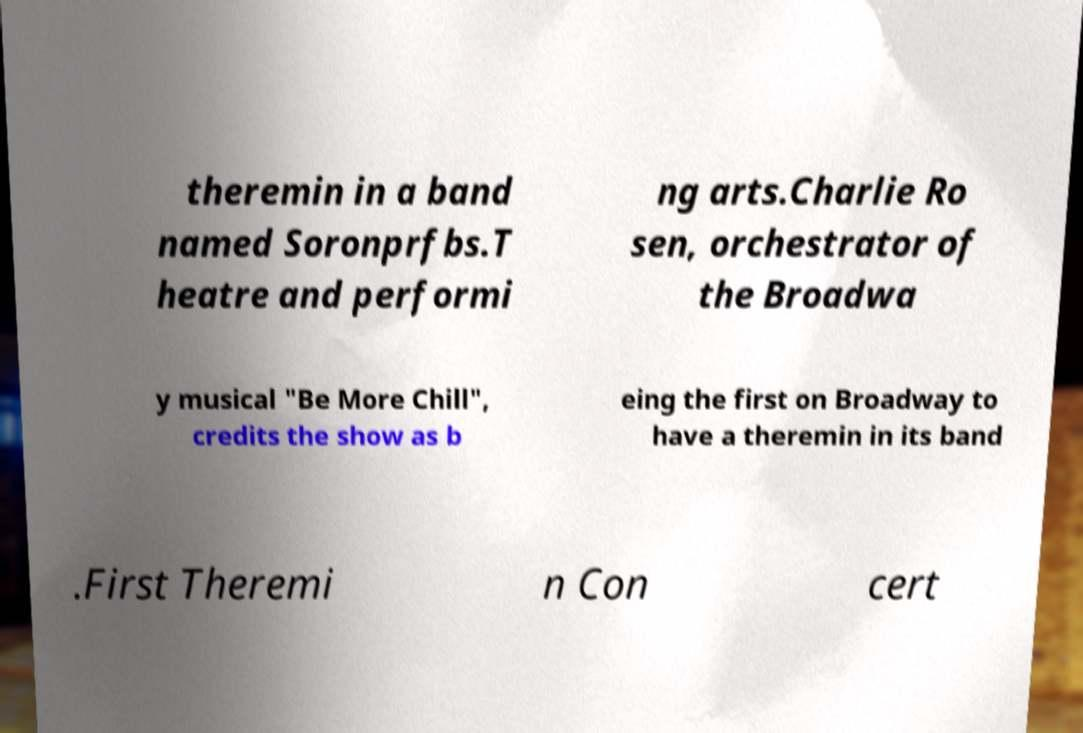Please identify and transcribe the text found in this image. theremin in a band named Soronprfbs.T heatre and performi ng arts.Charlie Ro sen, orchestrator of the Broadwa y musical "Be More Chill", credits the show as b eing the first on Broadway to have a theremin in its band .First Theremi n Con cert 